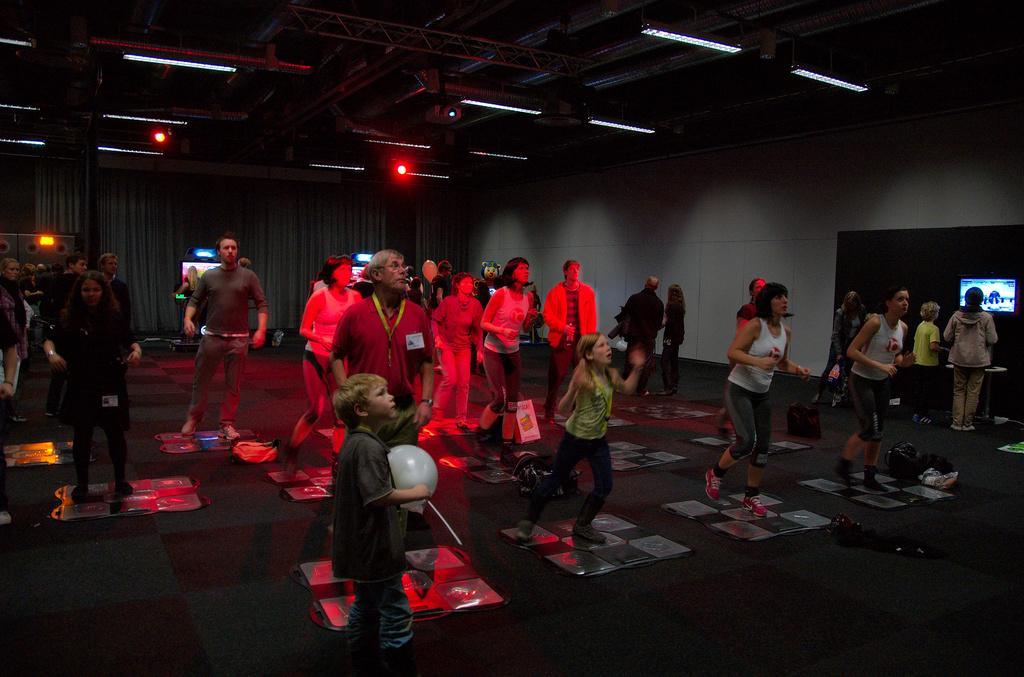Could you give a brief overview of what you see in this image? There are people and this boy holding a balloon. We can see boards and objects on the floor. In the background we can see table, screens, wall and curtains. At the top we can see lights. 